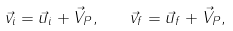<formula> <loc_0><loc_0><loc_500><loc_500>\vec { v } _ { i } = \vec { u } _ { i } + \vec { V } _ { P } , \quad \vec { v } _ { f } = \vec { u } _ { f } + \vec { V } _ { P } ,</formula> 